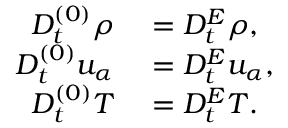<formula> <loc_0><loc_0><loc_500><loc_500>\begin{array} { r l } { D _ { t } ^ { ( 0 ) } \rho } & = D _ { t } ^ { E } \rho , } \\ { D _ { t } ^ { ( 0 ) } u _ { \alpha } } & = D _ { t } ^ { E } u _ { \alpha } , } \\ { D _ { t } ^ { ( 0 ) } T } & = D _ { t } ^ { E } T . } \end{array}</formula> 